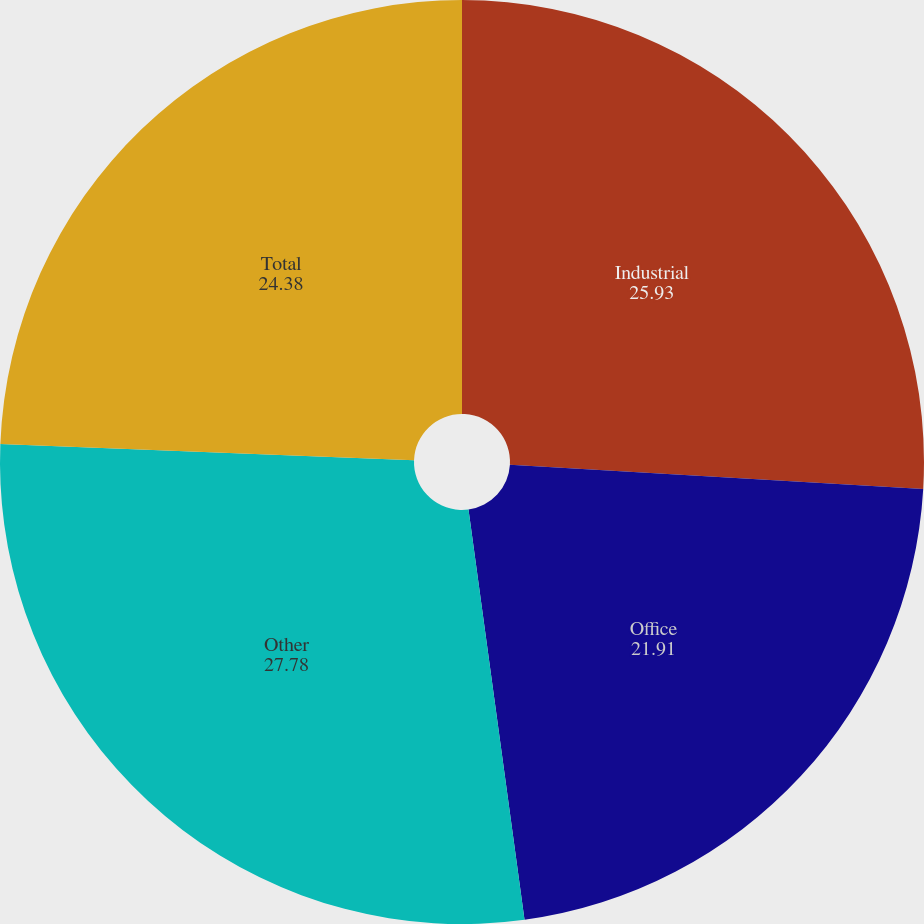<chart> <loc_0><loc_0><loc_500><loc_500><pie_chart><fcel>Industrial<fcel>Office<fcel>Other<fcel>Total<nl><fcel>25.93%<fcel>21.91%<fcel>27.78%<fcel>24.38%<nl></chart> 